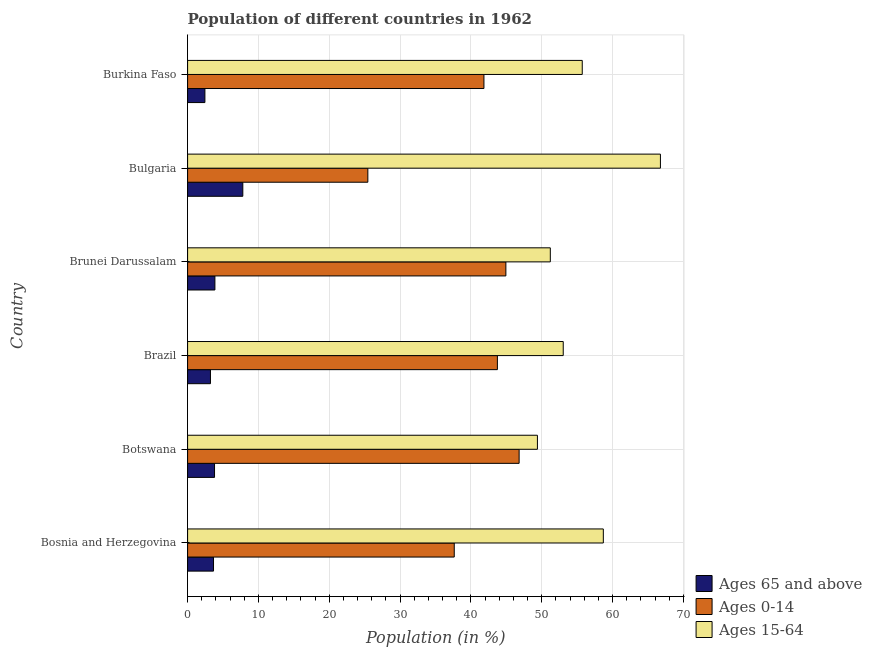How many different coloured bars are there?
Your response must be concise. 3. How many groups of bars are there?
Keep it short and to the point. 6. Are the number of bars per tick equal to the number of legend labels?
Offer a very short reply. Yes. Are the number of bars on each tick of the Y-axis equal?
Your answer should be very brief. Yes. How many bars are there on the 1st tick from the bottom?
Ensure brevity in your answer.  3. What is the label of the 2nd group of bars from the top?
Ensure brevity in your answer.  Bulgaria. In how many cases, is the number of bars for a given country not equal to the number of legend labels?
Provide a succinct answer. 0. What is the percentage of population within the age-group 0-14 in Bosnia and Herzegovina?
Your response must be concise. 37.65. Across all countries, what is the maximum percentage of population within the age-group of 65 and above?
Your response must be concise. 7.8. Across all countries, what is the minimum percentage of population within the age-group 15-64?
Offer a terse response. 49.39. In which country was the percentage of population within the age-group of 65 and above minimum?
Keep it short and to the point. Burkina Faso. What is the total percentage of population within the age-group 15-64 in the graph?
Give a very brief answer. 334.8. What is the difference between the percentage of population within the age-group 15-64 in Botswana and that in Burkina Faso?
Your answer should be very brief. -6.33. What is the difference between the percentage of population within the age-group of 65 and above in Bulgaria and the percentage of population within the age-group 15-64 in Brunei Darussalam?
Provide a succinct answer. -43.41. What is the average percentage of population within the age-group 15-64 per country?
Offer a terse response. 55.8. What is the difference between the percentage of population within the age-group 15-64 and percentage of population within the age-group of 65 and above in Bosnia and Herzegovina?
Ensure brevity in your answer.  55.03. In how many countries, is the percentage of population within the age-group 0-14 greater than 58 %?
Make the answer very short. 0. What is the ratio of the percentage of population within the age-group 0-14 in Bosnia and Herzegovina to that in Bulgaria?
Provide a short and direct response. 1.48. Is the percentage of population within the age-group of 65 and above in Brazil less than that in Brunei Darussalam?
Ensure brevity in your answer.  Yes. Is the difference between the percentage of population within the age-group 0-14 in Brunei Darussalam and Burkina Faso greater than the difference between the percentage of population within the age-group of 65 and above in Brunei Darussalam and Burkina Faso?
Keep it short and to the point. Yes. What is the difference between the highest and the second highest percentage of population within the age-group 0-14?
Give a very brief answer. 1.87. What is the difference between the highest and the lowest percentage of population within the age-group 15-64?
Offer a very short reply. 17.37. In how many countries, is the percentage of population within the age-group 0-14 greater than the average percentage of population within the age-group 0-14 taken over all countries?
Offer a very short reply. 4. What does the 2nd bar from the top in Bulgaria represents?
Give a very brief answer. Ages 0-14. What does the 1st bar from the bottom in Brazil represents?
Your answer should be compact. Ages 65 and above. Is it the case that in every country, the sum of the percentage of population within the age-group of 65 and above and percentage of population within the age-group 0-14 is greater than the percentage of population within the age-group 15-64?
Offer a very short reply. No. How many bars are there?
Your answer should be compact. 18. Are all the bars in the graph horizontal?
Keep it short and to the point. Yes. How many countries are there in the graph?
Your answer should be very brief. 6. What is the difference between two consecutive major ticks on the X-axis?
Offer a terse response. 10. Are the values on the major ticks of X-axis written in scientific E-notation?
Offer a very short reply. No. Does the graph contain any zero values?
Make the answer very short. No. How many legend labels are there?
Provide a succinct answer. 3. What is the title of the graph?
Provide a short and direct response. Population of different countries in 1962. Does "Total employers" appear as one of the legend labels in the graph?
Give a very brief answer. No. What is the label or title of the X-axis?
Your answer should be compact. Population (in %). What is the label or title of the Y-axis?
Make the answer very short. Country. What is the Population (in %) of Ages 65 and above in Bosnia and Herzegovina?
Your answer should be very brief. 3.66. What is the Population (in %) of Ages 0-14 in Bosnia and Herzegovina?
Your response must be concise. 37.65. What is the Population (in %) of Ages 15-64 in Bosnia and Herzegovina?
Your answer should be very brief. 58.69. What is the Population (in %) in Ages 65 and above in Botswana?
Make the answer very short. 3.8. What is the Population (in %) in Ages 0-14 in Botswana?
Your response must be concise. 46.81. What is the Population (in %) of Ages 15-64 in Botswana?
Provide a short and direct response. 49.39. What is the Population (in %) in Ages 65 and above in Brazil?
Keep it short and to the point. 3.23. What is the Population (in %) of Ages 0-14 in Brazil?
Give a very brief answer. 43.74. What is the Population (in %) of Ages 15-64 in Brazil?
Make the answer very short. 53.03. What is the Population (in %) of Ages 65 and above in Brunei Darussalam?
Provide a succinct answer. 3.85. What is the Population (in %) in Ages 0-14 in Brunei Darussalam?
Your response must be concise. 44.94. What is the Population (in %) in Ages 15-64 in Brunei Darussalam?
Offer a terse response. 51.21. What is the Population (in %) in Ages 65 and above in Bulgaria?
Provide a short and direct response. 7.8. What is the Population (in %) of Ages 0-14 in Bulgaria?
Provide a succinct answer. 25.45. What is the Population (in %) in Ages 15-64 in Bulgaria?
Ensure brevity in your answer.  66.76. What is the Population (in %) in Ages 65 and above in Burkina Faso?
Your response must be concise. 2.44. What is the Population (in %) of Ages 0-14 in Burkina Faso?
Offer a very short reply. 41.84. What is the Population (in %) of Ages 15-64 in Burkina Faso?
Your answer should be very brief. 55.72. Across all countries, what is the maximum Population (in %) of Ages 65 and above?
Your answer should be very brief. 7.8. Across all countries, what is the maximum Population (in %) in Ages 0-14?
Provide a succinct answer. 46.81. Across all countries, what is the maximum Population (in %) in Ages 15-64?
Make the answer very short. 66.76. Across all countries, what is the minimum Population (in %) in Ages 65 and above?
Ensure brevity in your answer.  2.44. Across all countries, what is the minimum Population (in %) in Ages 0-14?
Keep it short and to the point. 25.45. Across all countries, what is the minimum Population (in %) of Ages 15-64?
Ensure brevity in your answer.  49.39. What is the total Population (in %) in Ages 65 and above in the graph?
Keep it short and to the point. 24.78. What is the total Population (in %) in Ages 0-14 in the graph?
Your answer should be very brief. 240.41. What is the total Population (in %) in Ages 15-64 in the graph?
Your answer should be very brief. 334.8. What is the difference between the Population (in %) in Ages 65 and above in Bosnia and Herzegovina and that in Botswana?
Your answer should be compact. -0.14. What is the difference between the Population (in %) in Ages 0-14 in Bosnia and Herzegovina and that in Botswana?
Provide a succinct answer. -9.16. What is the difference between the Population (in %) of Ages 15-64 in Bosnia and Herzegovina and that in Botswana?
Your answer should be compact. 9.3. What is the difference between the Population (in %) in Ages 65 and above in Bosnia and Herzegovina and that in Brazil?
Your answer should be compact. 0.43. What is the difference between the Population (in %) in Ages 0-14 in Bosnia and Herzegovina and that in Brazil?
Give a very brief answer. -6.09. What is the difference between the Population (in %) in Ages 15-64 in Bosnia and Herzegovina and that in Brazil?
Give a very brief answer. 5.66. What is the difference between the Population (in %) of Ages 65 and above in Bosnia and Herzegovina and that in Brunei Darussalam?
Provide a succinct answer. -0.2. What is the difference between the Population (in %) in Ages 0-14 in Bosnia and Herzegovina and that in Brunei Darussalam?
Give a very brief answer. -7.29. What is the difference between the Population (in %) of Ages 15-64 in Bosnia and Herzegovina and that in Brunei Darussalam?
Keep it short and to the point. 7.48. What is the difference between the Population (in %) in Ages 65 and above in Bosnia and Herzegovina and that in Bulgaria?
Provide a short and direct response. -4.14. What is the difference between the Population (in %) in Ages 0-14 in Bosnia and Herzegovina and that in Bulgaria?
Your answer should be very brief. 12.2. What is the difference between the Population (in %) in Ages 15-64 in Bosnia and Herzegovina and that in Bulgaria?
Provide a short and direct response. -8.06. What is the difference between the Population (in %) in Ages 65 and above in Bosnia and Herzegovina and that in Burkina Faso?
Your answer should be very brief. 1.22. What is the difference between the Population (in %) in Ages 0-14 in Bosnia and Herzegovina and that in Burkina Faso?
Keep it short and to the point. -4.19. What is the difference between the Population (in %) in Ages 15-64 in Bosnia and Herzegovina and that in Burkina Faso?
Offer a very short reply. 2.98. What is the difference between the Population (in %) of Ages 65 and above in Botswana and that in Brazil?
Provide a succinct answer. 0.58. What is the difference between the Population (in %) in Ages 0-14 in Botswana and that in Brazil?
Keep it short and to the point. 3.07. What is the difference between the Population (in %) of Ages 15-64 in Botswana and that in Brazil?
Make the answer very short. -3.64. What is the difference between the Population (in %) in Ages 65 and above in Botswana and that in Brunei Darussalam?
Your answer should be very brief. -0.05. What is the difference between the Population (in %) of Ages 0-14 in Botswana and that in Brunei Darussalam?
Provide a succinct answer. 1.87. What is the difference between the Population (in %) of Ages 15-64 in Botswana and that in Brunei Darussalam?
Your answer should be compact. -1.82. What is the difference between the Population (in %) in Ages 65 and above in Botswana and that in Bulgaria?
Your answer should be compact. -3.99. What is the difference between the Population (in %) in Ages 0-14 in Botswana and that in Bulgaria?
Your answer should be very brief. 21.36. What is the difference between the Population (in %) of Ages 15-64 in Botswana and that in Bulgaria?
Provide a succinct answer. -17.37. What is the difference between the Population (in %) of Ages 65 and above in Botswana and that in Burkina Faso?
Offer a terse response. 1.36. What is the difference between the Population (in %) in Ages 0-14 in Botswana and that in Burkina Faso?
Keep it short and to the point. 4.97. What is the difference between the Population (in %) in Ages 15-64 in Botswana and that in Burkina Faso?
Your response must be concise. -6.33. What is the difference between the Population (in %) of Ages 65 and above in Brazil and that in Brunei Darussalam?
Keep it short and to the point. -0.63. What is the difference between the Population (in %) of Ages 0-14 in Brazil and that in Brunei Darussalam?
Ensure brevity in your answer.  -1.2. What is the difference between the Population (in %) in Ages 15-64 in Brazil and that in Brunei Darussalam?
Ensure brevity in your answer.  1.82. What is the difference between the Population (in %) of Ages 65 and above in Brazil and that in Bulgaria?
Your answer should be compact. -4.57. What is the difference between the Population (in %) of Ages 0-14 in Brazil and that in Bulgaria?
Offer a terse response. 18.29. What is the difference between the Population (in %) in Ages 15-64 in Brazil and that in Bulgaria?
Provide a succinct answer. -13.72. What is the difference between the Population (in %) of Ages 65 and above in Brazil and that in Burkina Faso?
Your response must be concise. 0.78. What is the difference between the Population (in %) of Ages 0-14 in Brazil and that in Burkina Faso?
Your response must be concise. 1.9. What is the difference between the Population (in %) of Ages 15-64 in Brazil and that in Burkina Faso?
Provide a short and direct response. -2.68. What is the difference between the Population (in %) in Ages 65 and above in Brunei Darussalam and that in Bulgaria?
Offer a terse response. -3.94. What is the difference between the Population (in %) of Ages 0-14 in Brunei Darussalam and that in Bulgaria?
Provide a short and direct response. 19.49. What is the difference between the Population (in %) in Ages 15-64 in Brunei Darussalam and that in Bulgaria?
Provide a short and direct response. -15.55. What is the difference between the Population (in %) of Ages 65 and above in Brunei Darussalam and that in Burkina Faso?
Make the answer very short. 1.41. What is the difference between the Population (in %) of Ages 0-14 in Brunei Darussalam and that in Burkina Faso?
Make the answer very short. 3.1. What is the difference between the Population (in %) of Ages 15-64 in Brunei Darussalam and that in Burkina Faso?
Offer a terse response. -4.51. What is the difference between the Population (in %) of Ages 65 and above in Bulgaria and that in Burkina Faso?
Keep it short and to the point. 5.35. What is the difference between the Population (in %) of Ages 0-14 in Bulgaria and that in Burkina Faso?
Offer a very short reply. -16.39. What is the difference between the Population (in %) of Ages 15-64 in Bulgaria and that in Burkina Faso?
Provide a succinct answer. 11.04. What is the difference between the Population (in %) of Ages 65 and above in Bosnia and Herzegovina and the Population (in %) of Ages 0-14 in Botswana?
Offer a very short reply. -43.15. What is the difference between the Population (in %) in Ages 65 and above in Bosnia and Herzegovina and the Population (in %) in Ages 15-64 in Botswana?
Ensure brevity in your answer.  -45.73. What is the difference between the Population (in %) in Ages 0-14 in Bosnia and Herzegovina and the Population (in %) in Ages 15-64 in Botswana?
Keep it short and to the point. -11.74. What is the difference between the Population (in %) of Ages 65 and above in Bosnia and Herzegovina and the Population (in %) of Ages 0-14 in Brazil?
Offer a terse response. -40.08. What is the difference between the Population (in %) in Ages 65 and above in Bosnia and Herzegovina and the Population (in %) in Ages 15-64 in Brazil?
Your response must be concise. -49.37. What is the difference between the Population (in %) in Ages 0-14 in Bosnia and Herzegovina and the Population (in %) in Ages 15-64 in Brazil?
Your answer should be very brief. -15.39. What is the difference between the Population (in %) of Ages 65 and above in Bosnia and Herzegovina and the Population (in %) of Ages 0-14 in Brunei Darussalam?
Make the answer very short. -41.28. What is the difference between the Population (in %) of Ages 65 and above in Bosnia and Herzegovina and the Population (in %) of Ages 15-64 in Brunei Darussalam?
Offer a terse response. -47.55. What is the difference between the Population (in %) of Ages 0-14 in Bosnia and Herzegovina and the Population (in %) of Ages 15-64 in Brunei Darussalam?
Ensure brevity in your answer.  -13.56. What is the difference between the Population (in %) in Ages 65 and above in Bosnia and Herzegovina and the Population (in %) in Ages 0-14 in Bulgaria?
Your response must be concise. -21.79. What is the difference between the Population (in %) of Ages 65 and above in Bosnia and Herzegovina and the Population (in %) of Ages 15-64 in Bulgaria?
Ensure brevity in your answer.  -63.1. What is the difference between the Population (in %) of Ages 0-14 in Bosnia and Herzegovina and the Population (in %) of Ages 15-64 in Bulgaria?
Keep it short and to the point. -29.11. What is the difference between the Population (in %) in Ages 65 and above in Bosnia and Herzegovina and the Population (in %) in Ages 0-14 in Burkina Faso?
Ensure brevity in your answer.  -38.18. What is the difference between the Population (in %) in Ages 65 and above in Bosnia and Herzegovina and the Population (in %) in Ages 15-64 in Burkina Faso?
Your answer should be very brief. -52.06. What is the difference between the Population (in %) in Ages 0-14 in Bosnia and Herzegovina and the Population (in %) in Ages 15-64 in Burkina Faso?
Ensure brevity in your answer.  -18.07. What is the difference between the Population (in %) in Ages 65 and above in Botswana and the Population (in %) in Ages 0-14 in Brazil?
Make the answer very short. -39.94. What is the difference between the Population (in %) in Ages 65 and above in Botswana and the Population (in %) in Ages 15-64 in Brazil?
Offer a very short reply. -49.23. What is the difference between the Population (in %) in Ages 0-14 in Botswana and the Population (in %) in Ages 15-64 in Brazil?
Provide a short and direct response. -6.23. What is the difference between the Population (in %) of Ages 65 and above in Botswana and the Population (in %) of Ages 0-14 in Brunei Darussalam?
Make the answer very short. -41.13. What is the difference between the Population (in %) of Ages 65 and above in Botswana and the Population (in %) of Ages 15-64 in Brunei Darussalam?
Make the answer very short. -47.41. What is the difference between the Population (in %) of Ages 0-14 in Botswana and the Population (in %) of Ages 15-64 in Brunei Darussalam?
Ensure brevity in your answer.  -4.4. What is the difference between the Population (in %) in Ages 65 and above in Botswana and the Population (in %) in Ages 0-14 in Bulgaria?
Make the answer very short. -21.64. What is the difference between the Population (in %) of Ages 65 and above in Botswana and the Population (in %) of Ages 15-64 in Bulgaria?
Offer a very short reply. -62.95. What is the difference between the Population (in %) in Ages 0-14 in Botswana and the Population (in %) in Ages 15-64 in Bulgaria?
Your answer should be compact. -19.95. What is the difference between the Population (in %) in Ages 65 and above in Botswana and the Population (in %) in Ages 0-14 in Burkina Faso?
Your response must be concise. -38.03. What is the difference between the Population (in %) of Ages 65 and above in Botswana and the Population (in %) of Ages 15-64 in Burkina Faso?
Your answer should be very brief. -51.91. What is the difference between the Population (in %) in Ages 0-14 in Botswana and the Population (in %) in Ages 15-64 in Burkina Faso?
Provide a succinct answer. -8.91. What is the difference between the Population (in %) of Ages 65 and above in Brazil and the Population (in %) of Ages 0-14 in Brunei Darussalam?
Your answer should be very brief. -41.71. What is the difference between the Population (in %) of Ages 65 and above in Brazil and the Population (in %) of Ages 15-64 in Brunei Darussalam?
Provide a short and direct response. -47.98. What is the difference between the Population (in %) in Ages 0-14 in Brazil and the Population (in %) in Ages 15-64 in Brunei Darussalam?
Make the answer very short. -7.47. What is the difference between the Population (in %) in Ages 65 and above in Brazil and the Population (in %) in Ages 0-14 in Bulgaria?
Make the answer very short. -22.22. What is the difference between the Population (in %) of Ages 65 and above in Brazil and the Population (in %) of Ages 15-64 in Bulgaria?
Make the answer very short. -63.53. What is the difference between the Population (in %) of Ages 0-14 in Brazil and the Population (in %) of Ages 15-64 in Bulgaria?
Make the answer very short. -23.02. What is the difference between the Population (in %) of Ages 65 and above in Brazil and the Population (in %) of Ages 0-14 in Burkina Faso?
Your answer should be compact. -38.61. What is the difference between the Population (in %) of Ages 65 and above in Brazil and the Population (in %) of Ages 15-64 in Burkina Faso?
Ensure brevity in your answer.  -52.49. What is the difference between the Population (in %) of Ages 0-14 in Brazil and the Population (in %) of Ages 15-64 in Burkina Faso?
Give a very brief answer. -11.98. What is the difference between the Population (in %) in Ages 65 and above in Brunei Darussalam and the Population (in %) in Ages 0-14 in Bulgaria?
Keep it short and to the point. -21.59. What is the difference between the Population (in %) in Ages 65 and above in Brunei Darussalam and the Population (in %) in Ages 15-64 in Bulgaria?
Your answer should be very brief. -62.9. What is the difference between the Population (in %) in Ages 0-14 in Brunei Darussalam and the Population (in %) in Ages 15-64 in Bulgaria?
Provide a succinct answer. -21.82. What is the difference between the Population (in %) in Ages 65 and above in Brunei Darussalam and the Population (in %) in Ages 0-14 in Burkina Faso?
Your answer should be compact. -37.98. What is the difference between the Population (in %) of Ages 65 and above in Brunei Darussalam and the Population (in %) of Ages 15-64 in Burkina Faso?
Your answer should be compact. -51.86. What is the difference between the Population (in %) of Ages 0-14 in Brunei Darussalam and the Population (in %) of Ages 15-64 in Burkina Faso?
Provide a short and direct response. -10.78. What is the difference between the Population (in %) of Ages 65 and above in Bulgaria and the Population (in %) of Ages 0-14 in Burkina Faso?
Offer a terse response. -34.04. What is the difference between the Population (in %) in Ages 65 and above in Bulgaria and the Population (in %) in Ages 15-64 in Burkina Faso?
Keep it short and to the point. -47.92. What is the difference between the Population (in %) of Ages 0-14 in Bulgaria and the Population (in %) of Ages 15-64 in Burkina Faso?
Make the answer very short. -30.27. What is the average Population (in %) in Ages 65 and above per country?
Offer a very short reply. 4.13. What is the average Population (in %) of Ages 0-14 per country?
Provide a succinct answer. 40.07. What is the average Population (in %) in Ages 15-64 per country?
Give a very brief answer. 55.8. What is the difference between the Population (in %) of Ages 65 and above and Population (in %) of Ages 0-14 in Bosnia and Herzegovina?
Provide a succinct answer. -33.99. What is the difference between the Population (in %) in Ages 65 and above and Population (in %) in Ages 15-64 in Bosnia and Herzegovina?
Make the answer very short. -55.03. What is the difference between the Population (in %) of Ages 0-14 and Population (in %) of Ages 15-64 in Bosnia and Herzegovina?
Your response must be concise. -21.05. What is the difference between the Population (in %) in Ages 65 and above and Population (in %) in Ages 0-14 in Botswana?
Offer a terse response. -43. What is the difference between the Population (in %) in Ages 65 and above and Population (in %) in Ages 15-64 in Botswana?
Your response must be concise. -45.59. What is the difference between the Population (in %) of Ages 0-14 and Population (in %) of Ages 15-64 in Botswana?
Keep it short and to the point. -2.58. What is the difference between the Population (in %) in Ages 65 and above and Population (in %) in Ages 0-14 in Brazil?
Make the answer very short. -40.51. What is the difference between the Population (in %) of Ages 65 and above and Population (in %) of Ages 15-64 in Brazil?
Offer a terse response. -49.81. What is the difference between the Population (in %) of Ages 0-14 and Population (in %) of Ages 15-64 in Brazil?
Your answer should be compact. -9.29. What is the difference between the Population (in %) in Ages 65 and above and Population (in %) in Ages 0-14 in Brunei Darussalam?
Offer a very short reply. -41.08. What is the difference between the Population (in %) in Ages 65 and above and Population (in %) in Ages 15-64 in Brunei Darussalam?
Keep it short and to the point. -47.35. What is the difference between the Population (in %) in Ages 0-14 and Population (in %) in Ages 15-64 in Brunei Darussalam?
Your answer should be very brief. -6.27. What is the difference between the Population (in %) of Ages 65 and above and Population (in %) of Ages 0-14 in Bulgaria?
Ensure brevity in your answer.  -17.65. What is the difference between the Population (in %) in Ages 65 and above and Population (in %) in Ages 15-64 in Bulgaria?
Keep it short and to the point. -58.96. What is the difference between the Population (in %) in Ages 0-14 and Population (in %) in Ages 15-64 in Bulgaria?
Offer a terse response. -41.31. What is the difference between the Population (in %) of Ages 65 and above and Population (in %) of Ages 0-14 in Burkina Faso?
Offer a very short reply. -39.39. What is the difference between the Population (in %) in Ages 65 and above and Population (in %) in Ages 15-64 in Burkina Faso?
Your answer should be very brief. -53.28. What is the difference between the Population (in %) in Ages 0-14 and Population (in %) in Ages 15-64 in Burkina Faso?
Keep it short and to the point. -13.88. What is the ratio of the Population (in %) of Ages 65 and above in Bosnia and Herzegovina to that in Botswana?
Keep it short and to the point. 0.96. What is the ratio of the Population (in %) in Ages 0-14 in Bosnia and Herzegovina to that in Botswana?
Your answer should be compact. 0.8. What is the ratio of the Population (in %) in Ages 15-64 in Bosnia and Herzegovina to that in Botswana?
Ensure brevity in your answer.  1.19. What is the ratio of the Population (in %) of Ages 65 and above in Bosnia and Herzegovina to that in Brazil?
Provide a short and direct response. 1.13. What is the ratio of the Population (in %) of Ages 0-14 in Bosnia and Herzegovina to that in Brazil?
Make the answer very short. 0.86. What is the ratio of the Population (in %) of Ages 15-64 in Bosnia and Herzegovina to that in Brazil?
Ensure brevity in your answer.  1.11. What is the ratio of the Population (in %) in Ages 65 and above in Bosnia and Herzegovina to that in Brunei Darussalam?
Make the answer very short. 0.95. What is the ratio of the Population (in %) in Ages 0-14 in Bosnia and Herzegovina to that in Brunei Darussalam?
Your answer should be compact. 0.84. What is the ratio of the Population (in %) of Ages 15-64 in Bosnia and Herzegovina to that in Brunei Darussalam?
Your response must be concise. 1.15. What is the ratio of the Population (in %) of Ages 65 and above in Bosnia and Herzegovina to that in Bulgaria?
Provide a short and direct response. 0.47. What is the ratio of the Population (in %) of Ages 0-14 in Bosnia and Herzegovina to that in Bulgaria?
Ensure brevity in your answer.  1.48. What is the ratio of the Population (in %) in Ages 15-64 in Bosnia and Herzegovina to that in Bulgaria?
Provide a short and direct response. 0.88. What is the ratio of the Population (in %) in Ages 65 and above in Bosnia and Herzegovina to that in Burkina Faso?
Give a very brief answer. 1.5. What is the ratio of the Population (in %) in Ages 0-14 in Bosnia and Herzegovina to that in Burkina Faso?
Give a very brief answer. 0.9. What is the ratio of the Population (in %) of Ages 15-64 in Bosnia and Herzegovina to that in Burkina Faso?
Your response must be concise. 1.05. What is the ratio of the Population (in %) in Ages 65 and above in Botswana to that in Brazil?
Your response must be concise. 1.18. What is the ratio of the Population (in %) of Ages 0-14 in Botswana to that in Brazil?
Your answer should be very brief. 1.07. What is the ratio of the Population (in %) of Ages 15-64 in Botswana to that in Brazil?
Make the answer very short. 0.93. What is the ratio of the Population (in %) of Ages 65 and above in Botswana to that in Brunei Darussalam?
Offer a very short reply. 0.99. What is the ratio of the Population (in %) in Ages 0-14 in Botswana to that in Brunei Darussalam?
Keep it short and to the point. 1.04. What is the ratio of the Population (in %) in Ages 15-64 in Botswana to that in Brunei Darussalam?
Offer a very short reply. 0.96. What is the ratio of the Population (in %) in Ages 65 and above in Botswana to that in Bulgaria?
Your response must be concise. 0.49. What is the ratio of the Population (in %) of Ages 0-14 in Botswana to that in Bulgaria?
Provide a succinct answer. 1.84. What is the ratio of the Population (in %) of Ages 15-64 in Botswana to that in Bulgaria?
Offer a terse response. 0.74. What is the ratio of the Population (in %) of Ages 65 and above in Botswana to that in Burkina Faso?
Make the answer very short. 1.56. What is the ratio of the Population (in %) in Ages 0-14 in Botswana to that in Burkina Faso?
Your answer should be very brief. 1.12. What is the ratio of the Population (in %) of Ages 15-64 in Botswana to that in Burkina Faso?
Your answer should be compact. 0.89. What is the ratio of the Population (in %) of Ages 65 and above in Brazil to that in Brunei Darussalam?
Offer a very short reply. 0.84. What is the ratio of the Population (in %) of Ages 0-14 in Brazil to that in Brunei Darussalam?
Provide a short and direct response. 0.97. What is the ratio of the Population (in %) of Ages 15-64 in Brazil to that in Brunei Darussalam?
Keep it short and to the point. 1.04. What is the ratio of the Population (in %) of Ages 65 and above in Brazil to that in Bulgaria?
Make the answer very short. 0.41. What is the ratio of the Population (in %) of Ages 0-14 in Brazil to that in Bulgaria?
Your response must be concise. 1.72. What is the ratio of the Population (in %) of Ages 15-64 in Brazil to that in Bulgaria?
Your response must be concise. 0.79. What is the ratio of the Population (in %) in Ages 65 and above in Brazil to that in Burkina Faso?
Offer a very short reply. 1.32. What is the ratio of the Population (in %) of Ages 0-14 in Brazil to that in Burkina Faso?
Give a very brief answer. 1.05. What is the ratio of the Population (in %) in Ages 15-64 in Brazil to that in Burkina Faso?
Your response must be concise. 0.95. What is the ratio of the Population (in %) in Ages 65 and above in Brunei Darussalam to that in Bulgaria?
Keep it short and to the point. 0.49. What is the ratio of the Population (in %) of Ages 0-14 in Brunei Darussalam to that in Bulgaria?
Your answer should be compact. 1.77. What is the ratio of the Population (in %) in Ages 15-64 in Brunei Darussalam to that in Bulgaria?
Keep it short and to the point. 0.77. What is the ratio of the Population (in %) in Ages 65 and above in Brunei Darussalam to that in Burkina Faso?
Make the answer very short. 1.58. What is the ratio of the Population (in %) of Ages 0-14 in Brunei Darussalam to that in Burkina Faso?
Your answer should be compact. 1.07. What is the ratio of the Population (in %) in Ages 15-64 in Brunei Darussalam to that in Burkina Faso?
Ensure brevity in your answer.  0.92. What is the ratio of the Population (in %) of Ages 65 and above in Bulgaria to that in Burkina Faso?
Make the answer very short. 3.19. What is the ratio of the Population (in %) in Ages 0-14 in Bulgaria to that in Burkina Faso?
Provide a succinct answer. 0.61. What is the ratio of the Population (in %) of Ages 15-64 in Bulgaria to that in Burkina Faso?
Your answer should be compact. 1.2. What is the difference between the highest and the second highest Population (in %) in Ages 65 and above?
Make the answer very short. 3.94. What is the difference between the highest and the second highest Population (in %) in Ages 0-14?
Keep it short and to the point. 1.87. What is the difference between the highest and the second highest Population (in %) of Ages 15-64?
Offer a very short reply. 8.06. What is the difference between the highest and the lowest Population (in %) of Ages 65 and above?
Provide a succinct answer. 5.35. What is the difference between the highest and the lowest Population (in %) of Ages 0-14?
Ensure brevity in your answer.  21.36. What is the difference between the highest and the lowest Population (in %) in Ages 15-64?
Your answer should be compact. 17.37. 